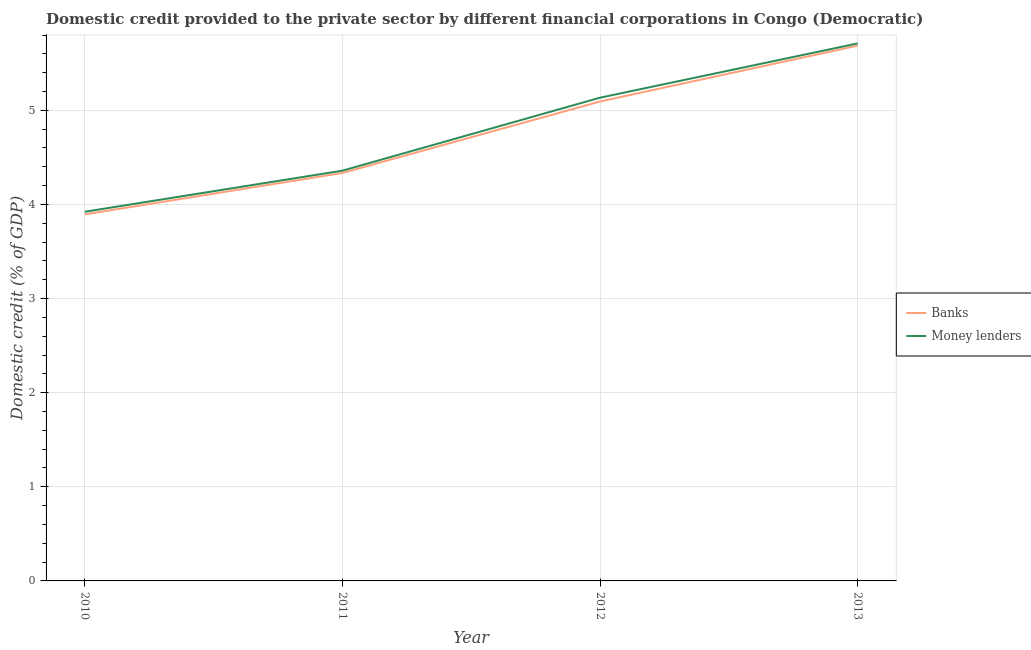How many different coloured lines are there?
Give a very brief answer. 2. What is the domestic credit provided by money lenders in 2012?
Give a very brief answer. 5.13. Across all years, what is the maximum domestic credit provided by banks?
Keep it short and to the point. 5.69. Across all years, what is the minimum domestic credit provided by banks?
Your response must be concise. 3.89. In which year was the domestic credit provided by money lenders minimum?
Ensure brevity in your answer.  2010. What is the total domestic credit provided by money lenders in the graph?
Your answer should be compact. 19.13. What is the difference between the domestic credit provided by money lenders in 2012 and that in 2013?
Your answer should be very brief. -0.58. What is the difference between the domestic credit provided by money lenders in 2013 and the domestic credit provided by banks in 2010?
Ensure brevity in your answer.  1.82. What is the average domestic credit provided by banks per year?
Keep it short and to the point. 4.75. In the year 2012, what is the difference between the domestic credit provided by money lenders and domestic credit provided by banks?
Provide a succinct answer. 0.04. In how many years, is the domestic credit provided by banks greater than 5 %?
Provide a short and direct response. 2. What is the ratio of the domestic credit provided by money lenders in 2010 to that in 2012?
Offer a terse response. 0.76. Is the domestic credit provided by money lenders in 2010 less than that in 2013?
Provide a succinct answer. Yes. What is the difference between the highest and the second highest domestic credit provided by banks?
Keep it short and to the point. 0.59. What is the difference between the highest and the lowest domestic credit provided by money lenders?
Provide a succinct answer. 1.79. Is the domestic credit provided by banks strictly less than the domestic credit provided by money lenders over the years?
Give a very brief answer. Yes. How many lines are there?
Your answer should be very brief. 2. What is the difference between two consecutive major ticks on the Y-axis?
Offer a terse response. 1. How many legend labels are there?
Make the answer very short. 2. How are the legend labels stacked?
Provide a short and direct response. Vertical. What is the title of the graph?
Ensure brevity in your answer.  Domestic credit provided to the private sector by different financial corporations in Congo (Democratic). Does "Health Care" appear as one of the legend labels in the graph?
Ensure brevity in your answer.  No. What is the label or title of the X-axis?
Offer a terse response. Year. What is the label or title of the Y-axis?
Give a very brief answer. Domestic credit (% of GDP). What is the Domestic credit (% of GDP) in Banks in 2010?
Offer a terse response. 3.89. What is the Domestic credit (% of GDP) of Money lenders in 2010?
Your response must be concise. 3.92. What is the Domestic credit (% of GDP) of Banks in 2011?
Your answer should be very brief. 4.33. What is the Domestic credit (% of GDP) in Money lenders in 2011?
Offer a terse response. 4.36. What is the Domestic credit (% of GDP) of Banks in 2012?
Your answer should be compact. 5.09. What is the Domestic credit (% of GDP) in Money lenders in 2012?
Make the answer very short. 5.13. What is the Domestic credit (% of GDP) of Banks in 2013?
Offer a very short reply. 5.69. What is the Domestic credit (% of GDP) of Money lenders in 2013?
Your response must be concise. 5.71. Across all years, what is the maximum Domestic credit (% of GDP) in Banks?
Keep it short and to the point. 5.69. Across all years, what is the maximum Domestic credit (% of GDP) in Money lenders?
Keep it short and to the point. 5.71. Across all years, what is the minimum Domestic credit (% of GDP) in Banks?
Make the answer very short. 3.89. Across all years, what is the minimum Domestic credit (% of GDP) in Money lenders?
Provide a short and direct response. 3.92. What is the total Domestic credit (% of GDP) of Banks in the graph?
Your answer should be compact. 19.01. What is the total Domestic credit (% of GDP) of Money lenders in the graph?
Give a very brief answer. 19.13. What is the difference between the Domestic credit (% of GDP) of Banks in 2010 and that in 2011?
Your response must be concise. -0.44. What is the difference between the Domestic credit (% of GDP) in Money lenders in 2010 and that in 2011?
Your answer should be compact. -0.44. What is the difference between the Domestic credit (% of GDP) of Banks in 2010 and that in 2012?
Your response must be concise. -1.2. What is the difference between the Domestic credit (% of GDP) of Money lenders in 2010 and that in 2012?
Provide a short and direct response. -1.21. What is the difference between the Domestic credit (% of GDP) of Banks in 2010 and that in 2013?
Your answer should be very brief. -1.79. What is the difference between the Domestic credit (% of GDP) of Money lenders in 2010 and that in 2013?
Offer a terse response. -1.79. What is the difference between the Domestic credit (% of GDP) of Banks in 2011 and that in 2012?
Offer a very short reply. -0.76. What is the difference between the Domestic credit (% of GDP) in Money lenders in 2011 and that in 2012?
Your response must be concise. -0.78. What is the difference between the Domestic credit (% of GDP) of Banks in 2011 and that in 2013?
Make the answer very short. -1.35. What is the difference between the Domestic credit (% of GDP) of Money lenders in 2011 and that in 2013?
Offer a very short reply. -1.35. What is the difference between the Domestic credit (% of GDP) in Banks in 2012 and that in 2013?
Offer a terse response. -0.59. What is the difference between the Domestic credit (% of GDP) in Money lenders in 2012 and that in 2013?
Keep it short and to the point. -0.58. What is the difference between the Domestic credit (% of GDP) of Banks in 2010 and the Domestic credit (% of GDP) of Money lenders in 2011?
Your response must be concise. -0.46. What is the difference between the Domestic credit (% of GDP) of Banks in 2010 and the Domestic credit (% of GDP) of Money lenders in 2012?
Ensure brevity in your answer.  -1.24. What is the difference between the Domestic credit (% of GDP) in Banks in 2010 and the Domestic credit (% of GDP) in Money lenders in 2013?
Offer a terse response. -1.82. What is the difference between the Domestic credit (% of GDP) in Banks in 2011 and the Domestic credit (% of GDP) in Money lenders in 2012?
Offer a very short reply. -0.8. What is the difference between the Domestic credit (% of GDP) of Banks in 2011 and the Domestic credit (% of GDP) of Money lenders in 2013?
Ensure brevity in your answer.  -1.38. What is the difference between the Domestic credit (% of GDP) in Banks in 2012 and the Domestic credit (% of GDP) in Money lenders in 2013?
Make the answer very short. -0.62. What is the average Domestic credit (% of GDP) in Banks per year?
Ensure brevity in your answer.  4.75. What is the average Domestic credit (% of GDP) in Money lenders per year?
Provide a short and direct response. 4.78. In the year 2010, what is the difference between the Domestic credit (% of GDP) of Banks and Domestic credit (% of GDP) of Money lenders?
Your answer should be very brief. -0.03. In the year 2011, what is the difference between the Domestic credit (% of GDP) of Banks and Domestic credit (% of GDP) of Money lenders?
Offer a terse response. -0.02. In the year 2012, what is the difference between the Domestic credit (% of GDP) of Banks and Domestic credit (% of GDP) of Money lenders?
Offer a very short reply. -0.04. In the year 2013, what is the difference between the Domestic credit (% of GDP) in Banks and Domestic credit (% of GDP) in Money lenders?
Your answer should be very brief. -0.02. What is the ratio of the Domestic credit (% of GDP) in Banks in 2010 to that in 2011?
Make the answer very short. 0.9. What is the ratio of the Domestic credit (% of GDP) of Money lenders in 2010 to that in 2011?
Give a very brief answer. 0.9. What is the ratio of the Domestic credit (% of GDP) of Banks in 2010 to that in 2012?
Your answer should be very brief. 0.76. What is the ratio of the Domestic credit (% of GDP) of Money lenders in 2010 to that in 2012?
Ensure brevity in your answer.  0.76. What is the ratio of the Domestic credit (% of GDP) in Banks in 2010 to that in 2013?
Provide a short and direct response. 0.68. What is the ratio of the Domestic credit (% of GDP) in Money lenders in 2010 to that in 2013?
Give a very brief answer. 0.69. What is the ratio of the Domestic credit (% of GDP) of Banks in 2011 to that in 2012?
Your answer should be compact. 0.85. What is the ratio of the Domestic credit (% of GDP) in Money lenders in 2011 to that in 2012?
Offer a terse response. 0.85. What is the ratio of the Domestic credit (% of GDP) in Banks in 2011 to that in 2013?
Make the answer very short. 0.76. What is the ratio of the Domestic credit (% of GDP) of Money lenders in 2011 to that in 2013?
Give a very brief answer. 0.76. What is the ratio of the Domestic credit (% of GDP) in Banks in 2012 to that in 2013?
Offer a terse response. 0.9. What is the ratio of the Domestic credit (% of GDP) in Money lenders in 2012 to that in 2013?
Offer a very short reply. 0.9. What is the difference between the highest and the second highest Domestic credit (% of GDP) of Banks?
Offer a very short reply. 0.59. What is the difference between the highest and the second highest Domestic credit (% of GDP) of Money lenders?
Ensure brevity in your answer.  0.58. What is the difference between the highest and the lowest Domestic credit (% of GDP) of Banks?
Provide a succinct answer. 1.79. What is the difference between the highest and the lowest Domestic credit (% of GDP) of Money lenders?
Make the answer very short. 1.79. 